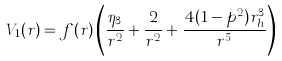<formula> <loc_0><loc_0><loc_500><loc_500>V _ { 1 } ( r ) = f ( r ) \left ( \frac { \eta _ { 3 } } { r ^ { 2 } } + \frac { 2 } { r ^ { 2 } } + \frac { 4 ( 1 - p ^ { 2 } ) r _ { h } ^ { 3 } } { r ^ { 5 } } \right )</formula> 